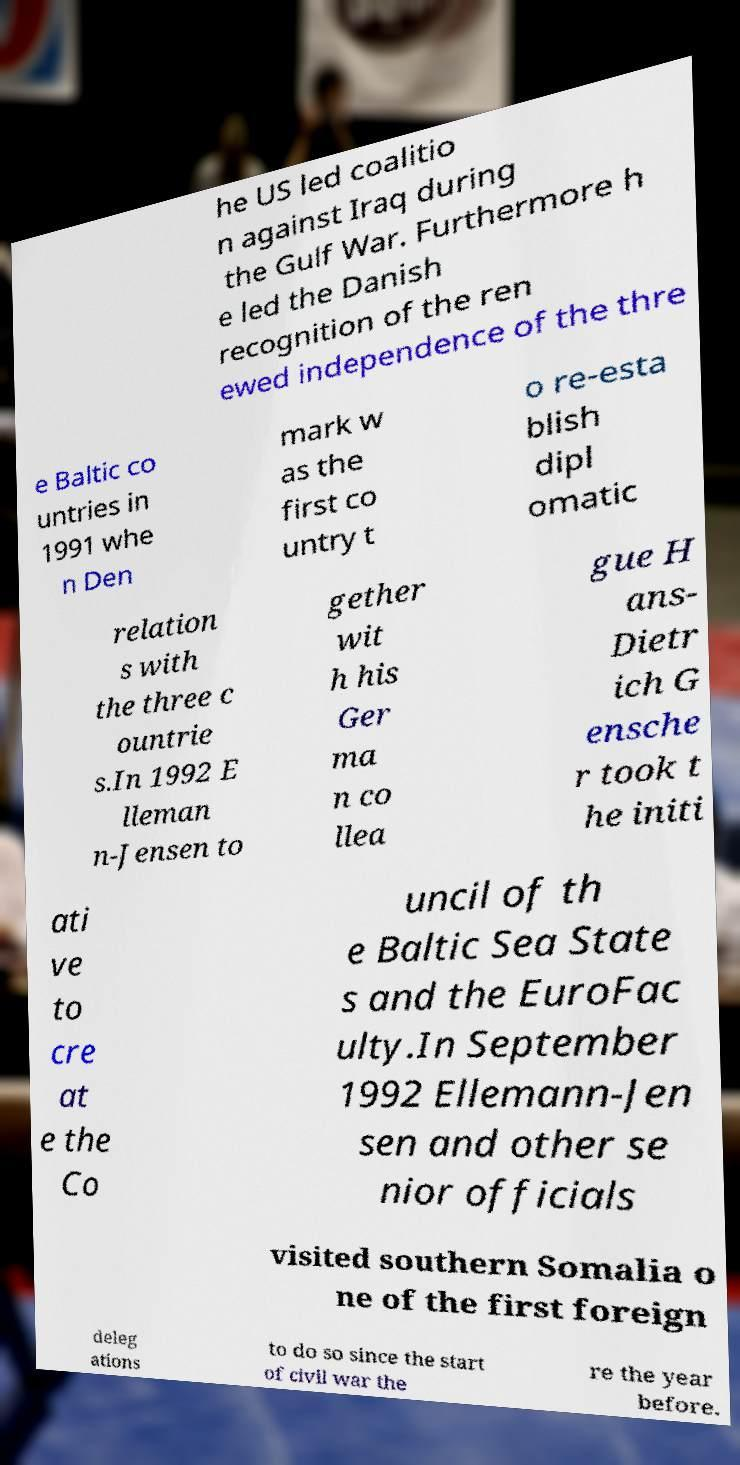What messages or text are displayed in this image? I need them in a readable, typed format. he US led coalitio n against Iraq during the Gulf War. Furthermore h e led the Danish recognition of the ren ewed independence of the thre e Baltic co untries in 1991 whe n Den mark w as the first co untry t o re-esta blish dipl omatic relation s with the three c ountrie s.In 1992 E lleman n-Jensen to gether wit h his Ger ma n co llea gue H ans- Dietr ich G ensche r took t he initi ati ve to cre at e the Co uncil of th e Baltic Sea State s and the EuroFac ulty.In September 1992 Ellemann-Jen sen and other se nior officials visited southern Somalia o ne of the first foreign deleg ations to do so since the start of civil war the re the year before. 